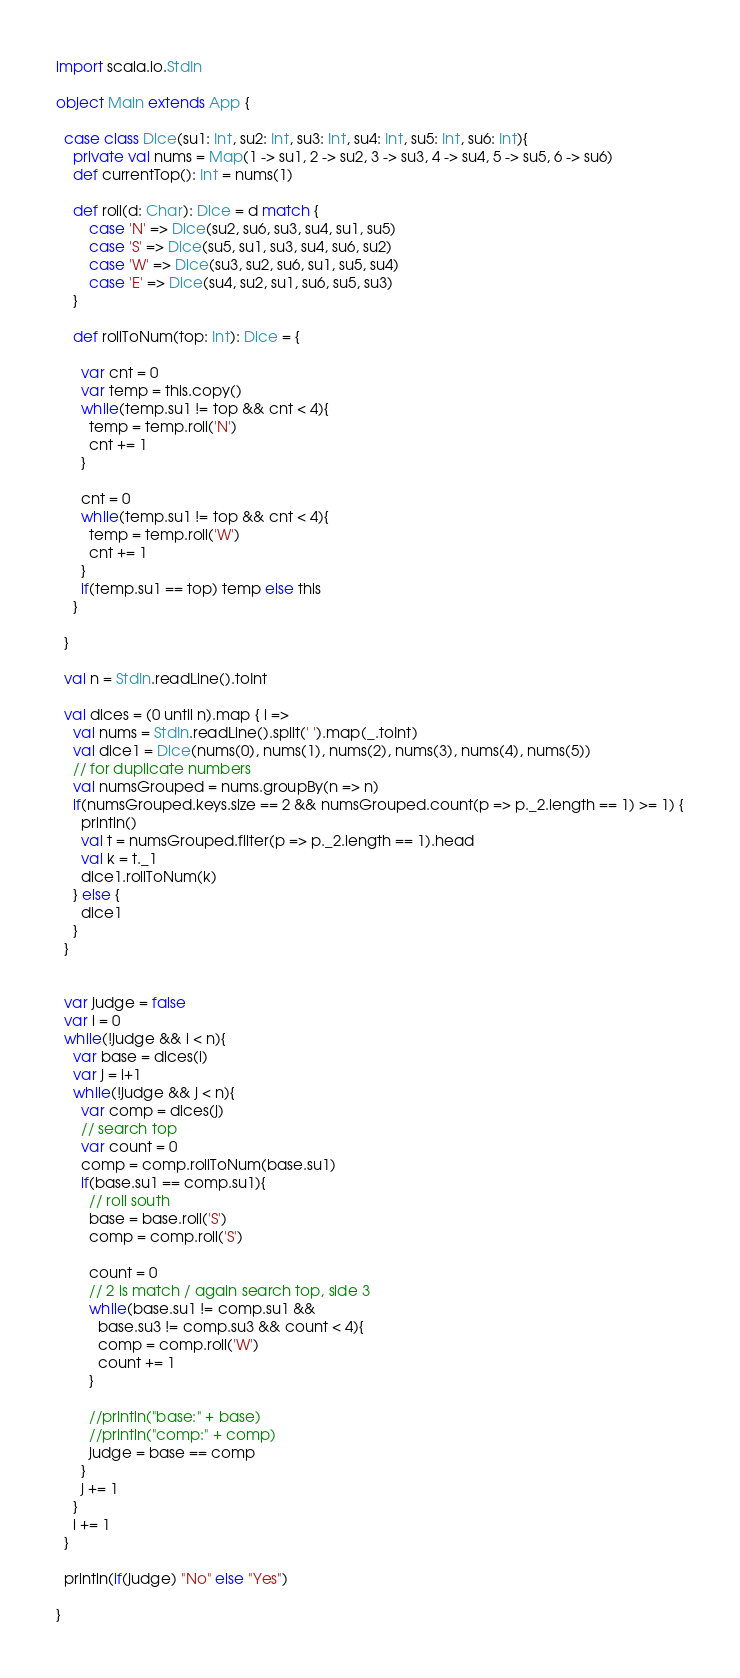Convert code to text. <code><loc_0><loc_0><loc_500><loc_500><_Scala_>import scala.io.StdIn

object Main extends App {

  case class Dice(su1: Int, su2: Int, su3: Int, su4: Int, su5: Int, su6: Int){
    private val nums = Map(1 -> su1, 2 -> su2, 3 -> su3, 4 -> su4, 5 -> su5, 6 -> su6)
    def currentTop(): Int = nums(1)
    
    def roll(d: Char): Dice = d match {
        case 'N' => Dice(su2, su6, su3, su4, su1, su5)
        case 'S' => Dice(su5, su1, su3, su4, su6, su2)
        case 'W' => Dice(su3, su2, su6, su1, su5, su4)
        case 'E' => Dice(su4, su2, su1, su6, su5, su3)
    }
    
    def rollToNum(top: Int): Dice = {
      
      var cnt = 0
      var temp = this.copy()
      while(temp.su1 != top && cnt < 4){
        temp = temp.roll('N')
        cnt += 1
      }

      cnt = 0
      while(temp.su1 != top && cnt < 4){
        temp = temp.roll('W')
        cnt += 1
      }
      if(temp.su1 == top) temp else this
    }
    
  }
  
  val n = StdIn.readLine().toInt

  val dices = (0 until n).map { i =>
    val nums = StdIn.readLine().split(' ').map(_.toInt)
    val dice1 = Dice(nums(0), nums(1), nums(2), nums(3), nums(4), nums(5))
    // for duplicate numbers
    val numsGrouped = nums.groupBy(n => n)
    if(numsGrouped.keys.size == 2 && numsGrouped.count(p => p._2.length == 1) >= 1) {
      println()
      val t = numsGrouped.filter(p => p._2.length == 1).head
      val k = t._1
      dice1.rollToNum(k)
    } else {
      dice1
    }
  }


  var judge = false
  var i = 0
  while(!judge && i < n){
    var base = dices(i)
    var j = i+1
    while(!judge && j < n){
      var comp = dices(j)
      // search top
      var count = 0
      comp = comp.rollToNum(base.su1)
      if(base.su1 == comp.su1){
        // roll south
        base = base.roll('S')
        comp = comp.roll('S')

        count = 0
        // 2 is match / again search top, side 3 
        while(base.su1 != comp.su1 &&
          base.su3 != comp.su3 && count < 4){
          comp = comp.roll('W')
          count += 1
        }
        
        //println("base:" + base)
        //println("comp:" + comp)
        judge = base == comp
      }
      j += 1
    }
    i += 1
  }
  
  println(if(judge) "No" else "Yes")
  
}
</code> 